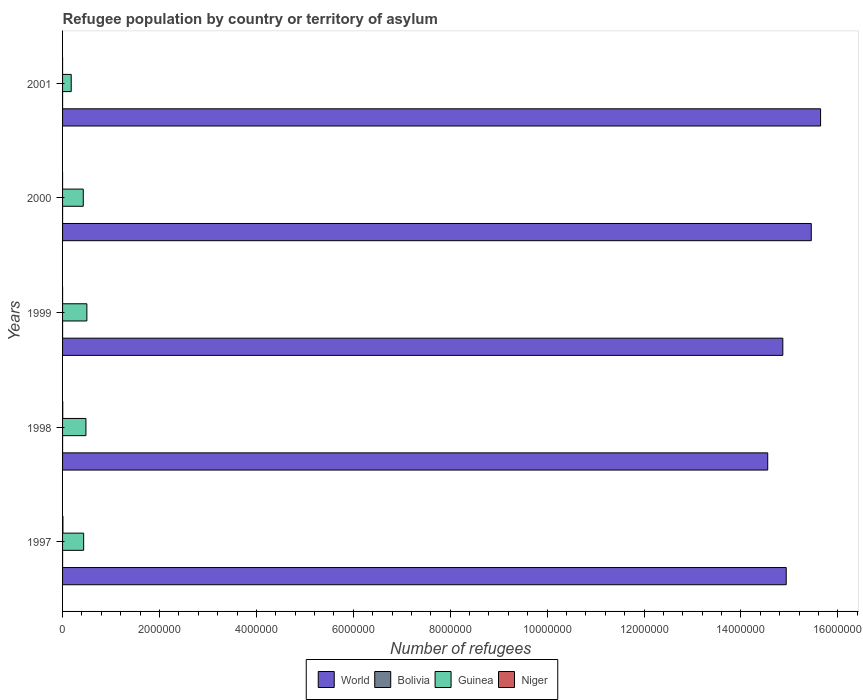How many groups of bars are there?
Offer a very short reply. 5. What is the number of refugees in Niger in 1997?
Make the answer very short. 7376. Across all years, what is the maximum number of refugees in World?
Your answer should be very brief. 1.56e+07. Across all years, what is the minimum number of refugees in Guinea?
Keep it short and to the point. 1.78e+05. What is the total number of refugees in World in the graph?
Provide a succinct answer. 7.54e+07. What is the difference between the number of refugees in Bolivia in 1998 and that in 2000?
Give a very brief answer. -2. What is the difference between the number of refugees in Guinea in 2000 and the number of refugees in World in 1999?
Offer a terse response. -1.44e+07. What is the average number of refugees in Niger per year?
Keep it short and to the point. 2311.6. In the year 1997, what is the difference between the number of refugees in World and number of refugees in Niger?
Offer a very short reply. 1.49e+07. In how many years, is the number of refugees in Bolivia greater than 6400000 ?
Your answer should be very brief. 0. What is the ratio of the number of refugees in Niger in 1998 to that in 2000?
Your response must be concise. 63.64. What is the difference between the highest and the second highest number of refugees in Niger?
Offer a very short reply. 3685. What is the difference between the highest and the lowest number of refugees in Guinea?
Your response must be concise. 3.23e+05. In how many years, is the number of refugees in Niger greater than the average number of refugees in Niger taken over all years?
Your response must be concise. 2. What does the 3rd bar from the bottom in 2001 represents?
Keep it short and to the point. Guinea. Is it the case that in every year, the sum of the number of refugees in Guinea and number of refugees in Bolivia is greater than the number of refugees in World?
Offer a very short reply. No. Are all the bars in the graph horizontal?
Offer a very short reply. Yes. What is the difference between two consecutive major ticks on the X-axis?
Your answer should be very brief. 2.00e+06. Are the values on the major ticks of X-axis written in scientific E-notation?
Make the answer very short. No. Does the graph contain any zero values?
Offer a terse response. No. What is the title of the graph?
Provide a short and direct response. Refugee population by country or territory of asylum. Does "New Caledonia" appear as one of the legend labels in the graph?
Ensure brevity in your answer.  No. What is the label or title of the X-axis?
Give a very brief answer. Number of refugees. What is the Number of refugees of World in 1997?
Offer a very short reply. 1.49e+07. What is the Number of refugees of Bolivia in 1997?
Make the answer very short. 333. What is the Number of refugees of Guinea in 1997?
Ensure brevity in your answer.  4.35e+05. What is the Number of refugees in Niger in 1997?
Give a very brief answer. 7376. What is the Number of refugees in World in 1998?
Keep it short and to the point. 1.46e+07. What is the Number of refugees of Bolivia in 1998?
Offer a terse response. 349. What is the Number of refugees of Guinea in 1998?
Make the answer very short. 4.82e+05. What is the Number of refugees of Niger in 1998?
Keep it short and to the point. 3691. What is the Number of refugees in World in 1999?
Keep it short and to the point. 1.49e+07. What is the Number of refugees in Bolivia in 1999?
Your answer should be very brief. 350. What is the Number of refugees of Guinea in 1999?
Your answer should be very brief. 5.02e+05. What is the Number of refugees of Niger in 1999?
Your response must be concise. 350. What is the Number of refugees in World in 2000?
Provide a succinct answer. 1.55e+07. What is the Number of refugees of Bolivia in 2000?
Ensure brevity in your answer.  351. What is the Number of refugees in Guinea in 2000?
Keep it short and to the point. 4.27e+05. What is the Number of refugees in Niger in 2000?
Offer a very short reply. 58. What is the Number of refugees in World in 2001?
Keep it short and to the point. 1.56e+07. What is the Number of refugees of Bolivia in 2001?
Ensure brevity in your answer.  347. What is the Number of refugees in Guinea in 2001?
Give a very brief answer. 1.78e+05. Across all years, what is the maximum Number of refugees of World?
Give a very brief answer. 1.56e+07. Across all years, what is the maximum Number of refugees in Bolivia?
Provide a succinct answer. 351. Across all years, what is the maximum Number of refugees in Guinea?
Offer a very short reply. 5.02e+05. Across all years, what is the maximum Number of refugees in Niger?
Your answer should be compact. 7376. Across all years, what is the minimum Number of refugees of World?
Your response must be concise. 1.46e+07. Across all years, what is the minimum Number of refugees in Bolivia?
Provide a short and direct response. 333. Across all years, what is the minimum Number of refugees of Guinea?
Keep it short and to the point. 1.78e+05. What is the total Number of refugees of World in the graph?
Provide a succinct answer. 7.54e+07. What is the total Number of refugees of Bolivia in the graph?
Offer a terse response. 1730. What is the total Number of refugees of Guinea in the graph?
Give a very brief answer. 2.02e+06. What is the total Number of refugees in Niger in the graph?
Make the answer very short. 1.16e+04. What is the difference between the Number of refugees of World in 1997 and that in 1998?
Your answer should be compact. 3.82e+05. What is the difference between the Number of refugees in Bolivia in 1997 and that in 1998?
Offer a very short reply. -16. What is the difference between the Number of refugees of Guinea in 1997 and that in 1998?
Provide a succinct answer. -4.72e+04. What is the difference between the Number of refugees of Niger in 1997 and that in 1998?
Offer a very short reply. 3685. What is the difference between the Number of refugees of World in 1997 and that in 1999?
Your answer should be very brief. 7.06e+04. What is the difference between the Number of refugees of Guinea in 1997 and that in 1999?
Offer a very short reply. -6.62e+04. What is the difference between the Number of refugees in Niger in 1997 and that in 1999?
Provide a succinct answer. 7026. What is the difference between the Number of refugees of World in 1997 and that in 2000?
Make the answer very short. -5.17e+05. What is the difference between the Number of refugees of Guinea in 1997 and that in 2000?
Your answer should be very brief. 8094. What is the difference between the Number of refugees of Niger in 1997 and that in 2000?
Your response must be concise. 7318. What is the difference between the Number of refugees in World in 1997 and that in 2001?
Offer a terse response. -7.09e+05. What is the difference between the Number of refugees in Bolivia in 1997 and that in 2001?
Ensure brevity in your answer.  -14. What is the difference between the Number of refugees of Guinea in 1997 and that in 2001?
Your response must be concise. 2.57e+05. What is the difference between the Number of refugees of Niger in 1997 and that in 2001?
Provide a short and direct response. 7293. What is the difference between the Number of refugees in World in 1998 and that in 1999?
Give a very brief answer. -3.12e+05. What is the difference between the Number of refugees of Bolivia in 1998 and that in 1999?
Ensure brevity in your answer.  -1. What is the difference between the Number of refugees in Guinea in 1998 and that in 1999?
Offer a very short reply. -1.91e+04. What is the difference between the Number of refugees of Niger in 1998 and that in 1999?
Make the answer very short. 3341. What is the difference between the Number of refugees in World in 1998 and that in 2000?
Your answer should be compact. -8.99e+05. What is the difference between the Number of refugees in Bolivia in 1998 and that in 2000?
Your answer should be compact. -2. What is the difference between the Number of refugees in Guinea in 1998 and that in 2000?
Provide a succinct answer. 5.53e+04. What is the difference between the Number of refugees in Niger in 1998 and that in 2000?
Keep it short and to the point. 3633. What is the difference between the Number of refugees in World in 1998 and that in 2001?
Provide a succinct answer. -1.09e+06. What is the difference between the Number of refugees in Guinea in 1998 and that in 2001?
Provide a succinct answer. 3.04e+05. What is the difference between the Number of refugees of Niger in 1998 and that in 2001?
Provide a succinct answer. 3608. What is the difference between the Number of refugees in World in 1999 and that in 2000?
Provide a short and direct response. -5.87e+05. What is the difference between the Number of refugees of Bolivia in 1999 and that in 2000?
Offer a terse response. -1. What is the difference between the Number of refugees in Guinea in 1999 and that in 2000?
Your response must be concise. 7.43e+04. What is the difference between the Number of refugees in Niger in 1999 and that in 2000?
Provide a short and direct response. 292. What is the difference between the Number of refugees of World in 1999 and that in 2001?
Your answer should be very brief. -7.79e+05. What is the difference between the Number of refugees of Guinea in 1999 and that in 2001?
Your response must be concise. 3.23e+05. What is the difference between the Number of refugees in Niger in 1999 and that in 2001?
Give a very brief answer. 267. What is the difference between the Number of refugees in World in 2000 and that in 2001?
Your answer should be compact. -1.92e+05. What is the difference between the Number of refugees of Guinea in 2000 and that in 2001?
Give a very brief answer. 2.49e+05. What is the difference between the Number of refugees of Niger in 2000 and that in 2001?
Make the answer very short. -25. What is the difference between the Number of refugees of World in 1997 and the Number of refugees of Bolivia in 1998?
Make the answer very short. 1.49e+07. What is the difference between the Number of refugees in World in 1997 and the Number of refugees in Guinea in 1998?
Ensure brevity in your answer.  1.45e+07. What is the difference between the Number of refugees in World in 1997 and the Number of refugees in Niger in 1998?
Your response must be concise. 1.49e+07. What is the difference between the Number of refugees in Bolivia in 1997 and the Number of refugees in Guinea in 1998?
Your answer should be compact. -4.82e+05. What is the difference between the Number of refugees of Bolivia in 1997 and the Number of refugees of Niger in 1998?
Offer a very short reply. -3358. What is the difference between the Number of refugees in Guinea in 1997 and the Number of refugees in Niger in 1998?
Provide a succinct answer. 4.32e+05. What is the difference between the Number of refugees in World in 1997 and the Number of refugees in Bolivia in 1999?
Provide a short and direct response. 1.49e+07. What is the difference between the Number of refugees of World in 1997 and the Number of refugees of Guinea in 1999?
Give a very brief answer. 1.44e+07. What is the difference between the Number of refugees of World in 1997 and the Number of refugees of Niger in 1999?
Offer a very short reply. 1.49e+07. What is the difference between the Number of refugees in Bolivia in 1997 and the Number of refugees in Guinea in 1999?
Your answer should be very brief. -5.01e+05. What is the difference between the Number of refugees of Bolivia in 1997 and the Number of refugees of Niger in 1999?
Give a very brief answer. -17. What is the difference between the Number of refugees of Guinea in 1997 and the Number of refugees of Niger in 1999?
Ensure brevity in your answer.  4.35e+05. What is the difference between the Number of refugees of World in 1997 and the Number of refugees of Bolivia in 2000?
Your answer should be very brief. 1.49e+07. What is the difference between the Number of refugees of World in 1997 and the Number of refugees of Guinea in 2000?
Provide a succinct answer. 1.45e+07. What is the difference between the Number of refugees of World in 1997 and the Number of refugees of Niger in 2000?
Provide a short and direct response. 1.49e+07. What is the difference between the Number of refugees in Bolivia in 1997 and the Number of refugees in Guinea in 2000?
Ensure brevity in your answer.  -4.27e+05. What is the difference between the Number of refugees in Bolivia in 1997 and the Number of refugees in Niger in 2000?
Provide a succinct answer. 275. What is the difference between the Number of refugees in Guinea in 1997 and the Number of refugees in Niger in 2000?
Provide a short and direct response. 4.35e+05. What is the difference between the Number of refugees of World in 1997 and the Number of refugees of Bolivia in 2001?
Offer a terse response. 1.49e+07. What is the difference between the Number of refugees in World in 1997 and the Number of refugees in Guinea in 2001?
Your answer should be compact. 1.48e+07. What is the difference between the Number of refugees of World in 1997 and the Number of refugees of Niger in 2001?
Give a very brief answer. 1.49e+07. What is the difference between the Number of refugees of Bolivia in 1997 and the Number of refugees of Guinea in 2001?
Your answer should be very brief. -1.78e+05. What is the difference between the Number of refugees in Bolivia in 1997 and the Number of refugees in Niger in 2001?
Give a very brief answer. 250. What is the difference between the Number of refugees in Guinea in 1997 and the Number of refugees in Niger in 2001?
Ensure brevity in your answer.  4.35e+05. What is the difference between the Number of refugees in World in 1998 and the Number of refugees in Bolivia in 1999?
Ensure brevity in your answer.  1.46e+07. What is the difference between the Number of refugees of World in 1998 and the Number of refugees of Guinea in 1999?
Make the answer very short. 1.41e+07. What is the difference between the Number of refugees in World in 1998 and the Number of refugees in Niger in 1999?
Ensure brevity in your answer.  1.46e+07. What is the difference between the Number of refugees of Bolivia in 1998 and the Number of refugees of Guinea in 1999?
Keep it short and to the point. -5.01e+05. What is the difference between the Number of refugees of Guinea in 1998 and the Number of refugees of Niger in 1999?
Your answer should be very brief. 4.82e+05. What is the difference between the Number of refugees in World in 1998 and the Number of refugees in Bolivia in 2000?
Ensure brevity in your answer.  1.46e+07. What is the difference between the Number of refugees of World in 1998 and the Number of refugees of Guinea in 2000?
Provide a succinct answer. 1.41e+07. What is the difference between the Number of refugees in World in 1998 and the Number of refugees in Niger in 2000?
Ensure brevity in your answer.  1.46e+07. What is the difference between the Number of refugees in Bolivia in 1998 and the Number of refugees in Guinea in 2000?
Your response must be concise. -4.27e+05. What is the difference between the Number of refugees in Bolivia in 1998 and the Number of refugees in Niger in 2000?
Your response must be concise. 291. What is the difference between the Number of refugees in Guinea in 1998 and the Number of refugees in Niger in 2000?
Ensure brevity in your answer.  4.82e+05. What is the difference between the Number of refugees in World in 1998 and the Number of refugees in Bolivia in 2001?
Provide a succinct answer. 1.46e+07. What is the difference between the Number of refugees in World in 1998 and the Number of refugees in Guinea in 2001?
Make the answer very short. 1.44e+07. What is the difference between the Number of refugees of World in 1998 and the Number of refugees of Niger in 2001?
Make the answer very short. 1.46e+07. What is the difference between the Number of refugees of Bolivia in 1998 and the Number of refugees of Guinea in 2001?
Your response must be concise. -1.78e+05. What is the difference between the Number of refugees in Bolivia in 1998 and the Number of refugees in Niger in 2001?
Your answer should be very brief. 266. What is the difference between the Number of refugees in Guinea in 1998 and the Number of refugees in Niger in 2001?
Keep it short and to the point. 4.82e+05. What is the difference between the Number of refugees of World in 1999 and the Number of refugees of Bolivia in 2000?
Your answer should be compact. 1.49e+07. What is the difference between the Number of refugees in World in 1999 and the Number of refugees in Guinea in 2000?
Your response must be concise. 1.44e+07. What is the difference between the Number of refugees of World in 1999 and the Number of refugees of Niger in 2000?
Give a very brief answer. 1.49e+07. What is the difference between the Number of refugees in Bolivia in 1999 and the Number of refugees in Guinea in 2000?
Ensure brevity in your answer.  -4.27e+05. What is the difference between the Number of refugees in Bolivia in 1999 and the Number of refugees in Niger in 2000?
Offer a very short reply. 292. What is the difference between the Number of refugees in Guinea in 1999 and the Number of refugees in Niger in 2000?
Your answer should be very brief. 5.01e+05. What is the difference between the Number of refugees in World in 1999 and the Number of refugees in Bolivia in 2001?
Offer a terse response. 1.49e+07. What is the difference between the Number of refugees in World in 1999 and the Number of refugees in Guinea in 2001?
Your answer should be very brief. 1.47e+07. What is the difference between the Number of refugees in World in 1999 and the Number of refugees in Niger in 2001?
Keep it short and to the point. 1.49e+07. What is the difference between the Number of refugees in Bolivia in 1999 and the Number of refugees in Guinea in 2001?
Provide a succinct answer. -1.78e+05. What is the difference between the Number of refugees of Bolivia in 1999 and the Number of refugees of Niger in 2001?
Provide a short and direct response. 267. What is the difference between the Number of refugees in Guinea in 1999 and the Number of refugees in Niger in 2001?
Your answer should be very brief. 5.01e+05. What is the difference between the Number of refugees of World in 2000 and the Number of refugees of Bolivia in 2001?
Your answer should be very brief. 1.55e+07. What is the difference between the Number of refugees of World in 2000 and the Number of refugees of Guinea in 2001?
Ensure brevity in your answer.  1.53e+07. What is the difference between the Number of refugees in World in 2000 and the Number of refugees in Niger in 2001?
Give a very brief answer. 1.55e+07. What is the difference between the Number of refugees in Bolivia in 2000 and the Number of refugees in Guinea in 2001?
Keep it short and to the point. -1.78e+05. What is the difference between the Number of refugees of Bolivia in 2000 and the Number of refugees of Niger in 2001?
Ensure brevity in your answer.  268. What is the difference between the Number of refugees of Guinea in 2000 and the Number of refugees of Niger in 2001?
Keep it short and to the point. 4.27e+05. What is the average Number of refugees in World per year?
Keep it short and to the point. 1.51e+07. What is the average Number of refugees of Bolivia per year?
Your answer should be very brief. 346. What is the average Number of refugees in Guinea per year?
Provide a succinct answer. 4.05e+05. What is the average Number of refugees of Niger per year?
Make the answer very short. 2311.6. In the year 1997, what is the difference between the Number of refugees of World and Number of refugees of Bolivia?
Make the answer very short. 1.49e+07. In the year 1997, what is the difference between the Number of refugees of World and Number of refugees of Guinea?
Provide a succinct answer. 1.45e+07. In the year 1997, what is the difference between the Number of refugees of World and Number of refugees of Niger?
Offer a very short reply. 1.49e+07. In the year 1997, what is the difference between the Number of refugees in Bolivia and Number of refugees in Guinea?
Ensure brevity in your answer.  -4.35e+05. In the year 1997, what is the difference between the Number of refugees of Bolivia and Number of refugees of Niger?
Offer a terse response. -7043. In the year 1997, what is the difference between the Number of refugees of Guinea and Number of refugees of Niger?
Offer a very short reply. 4.28e+05. In the year 1998, what is the difference between the Number of refugees in World and Number of refugees in Bolivia?
Ensure brevity in your answer.  1.46e+07. In the year 1998, what is the difference between the Number of refugees of World and Number of refugees of Guinea?
Ensure brevity in your answer.  1.41e+07. In the year 1998, what is the difference between the Number of refugees of World and Number of refugees of Niger?
Your answer should be compact. 1.45e+07. In the year 1998, what is the difference between the Number of refugees in Bolivia and Number of refugees in Guinea?
Provide a short and direct response. -4.82e+05. In the year 1998, what is the difference between the Number of refugees in Bolivia and Number of refugees in Niger?
Your answer should be compact. -3342. In the year 1998, what is the difference between the Number of refugees of Guinea and Number of refugees of Niger?
Provide a short and direct response. 4.79e+05. In the year 1999, what is the difference between the Number of refugees of World and Number of refugees of Bolivia?
Provide a short and direct response. 1.49e+07. In the year 1999, what is the difference between the Number of refugees in World and Number of refugees in Guinea?
Keep it short and to the point. 1.44e+07. In the year 1999, what is the difference between the Number of refugees of World and Number of refugees of Niger?
Ensure brevity in your answer.  1.49e+07. In the year 1999, what is the difference between the Number of refugees in Bolivia and Number of refugees in Guinea?
Your response must be concise. -5.01e+05. In the year 1999, what is the difference between the Number of refugees of Guinea and Number of refugees of Niger?
Provide a succinct answer. 5.01e+05. In the year 2000, what is the difference between the Number of refugees in World and Number of refugees in Bolivia?
Offer a very short reply. 1.55e+07. In the year 2000, what is the difference between the Number of refugees of World and Number of refugees of Guinea?
Keep it short and to the point. 1.50e+07. In the year 2000, what is the difference between the Number of refugees in World and Number of refugees in Niger?
Provide a short and direct response. 1.55e+07. In the year 2000, what is the difference between the Number of refugees in Bolivia and Number of refugees in Guinea?
Offer a very short reply. -4.27e+05. In the year 2000, what is the difference between the Number of refugees in Bolivia and Number of refugees in Niger?
Provide a short and direct response. 293. In the year 2000, what is the difference between the Number of refugees in Guinea and Number of refugees in Niger?
Offer a very short reply. 4.27e+05. In the year 2001, what is the difference between the Number of refugees in World and Number of refugees in Bolivia?
Give a very brief answer. 1.56e+07. In the year 2001, what is the difference between the Number of refugees of World and Number of refugees of Guinea?
Provide a short and direct response. 1.55e+07. In the year 2001, what is the difference between the Number of refugees in World and Number of refugees in Niger?
Make the answer very short. 1.56e+07. In the year 2001, what is the difference between the Number of refugees in Bolivia and Number of refugees in Guinea?
Provide a succinct answer. -1.78e+05. In the year 2001, what is the difference between the Number of refugees of Bolivia and Number of refugees of Niger?
Ensure brevity in your answer.  264. In the year 2001, what is the difference between the Number of refugees of Guinea and Number of refugees of Niger?
Provide a succinct answer. 1.78e+05. What is the ratio of the Number of refugees in World in 1997 to that in 1998?
Provide a short and direct response. 1.03. What is the ratio of the Number of refugees in Bolivia in 1997 to that in 1998?
Keep it short and to the point. 0.95. What is the ratio of the Number of refugees of Guinea in 1997 to that in 1998?
Keep it short and to the point. 0.9. What is the ratio of the Number of refugees in Niger in 1997 to that in 1998?
Ensure brevity in your answer.  2. What is the ratio of the Number of refugees in Bolivia in 1997 to that in 1999?
Make the answer very short. 0.95. What is the ratio of the Number of refugees of Guinea in 1997 to that in 1999?
Give a very brief answer. 0.87. What is the ratio of the Number of refugees of Niger in 1997 to that in 1999?
Your answer should be very brief. 21.07. What is the ratio of the Number of refugees of World in 1997 to that in 2000?
Your response must be concise. 0.97. What is the ratio of the Number of refugees of Bolivia in 1997 to that in 2000?
Provide a short and direct response. 0.95. What is the ratio of the Number of refugees in Guinea in 1997 to that in 2000?
Your answer should be very brief. 1.02. What is the ratio of the Number of refugees of Niger in 1997 to that in 2000?
Provide a succinct answer. 127.17. What is the ratio of the Number of refugees in World in 1997 to that in 2001?
Keep it short and to the point. 0.95. What is the ratio of the Number of refugees in Bolivia in 1997 to that in 2001?
Keep it short and to the point. 0.96. What is the ratio of the Number of refugees of Guinea in 1997 to that in 2001?
Ensure brevity in your answer.  2.44. What is the ratio of the Number of refugees of Niger in 1997 to that in 2001?
Your response must be concise. 88.87. What is the ratio of the Number of refugees of Bolivia in 1998 to that in 1999?
Give a very brief answer. 1. What is the ratio of the Number of refugees of Niger in 1998 to that in 1999?
Your response must be concise. 10.55. What is the ratio of the Number of refugees in World in 1998 to that in 2000?
Give a very brief answer. 0.94. What is the ratio of the Number of refugees of Bolivia in 1998 to that in 2000?
Give a very brief answer. 0.99. What is the ratio of the Number of refugees of Guinea in 1998 to that in 2000?
Provide a short and direct response. 1.13. What is the ratio of the Number of refugees in Niger in 1998 to that in 2000?
Give a very brief answer. 63.64. What is the ratio of the Number of refugees of World in 1998 to that in 2001?
Your answer should be very brief. 0.93. What is the ratio of the Number of refugees of Guinea in 1998 to that in 2001?
Your answer should be compact. 2.7. What is the ratio of the Number of refugees of Niger in 1998 to that in 2001?
Your answer should be compact. 44.47. What is the ratio of the Number of refugees of Bolivia in 1999 to that in 2000?
Your response must be concise. 1. What is the ratio of the Number of refugees in Guinea in 1999 to that in 2000?
Keep it short and to the point. 1.17. What is the ratio of the Number of refugees in Niger in 1999 to that in 2000?
Provide a short and direct response. 6.03. What is the ratio of the Number of refugees of World in 1999 to that in 2001?
Your answer should be compact. 0.95. What is the ratio of the Number of refugees in Bolivia in 1999 to that in 2001?
Keep it short and to the point. 1.01. What is the ratio of the Number of refugees in Guinea in 1999 to that in 2001?
Give a very brief answer. 2.81. What is the ratio of the Number of refugees of Niger in 1999 to that in 2001?
Your answer should be compact. 4.22. What is the ratio of the Number of refugees of World in 2000 to that in 2001?
Your answer should be very brief. 0.99. What is the ratio of the Number of refugees of Bolivia in 2000 to that in 2001?
Give a very brief answer. 1.01. What is the ratio of the Number of refugees of Guinea in 2000 to that in 2001?
Your response must be concise. 2.39. What is the ratio of the Number of refugees of Niger in 2000 to that in 2001?
Make the answer very short. 0.7. What is the difference between the highest and the second highest Number of refugees in World?
Your answer should be very brief. 1.92e+05. What is the difference between the highest and the second highest Number of refugees of Bolivia?
Your answer should be compact. 1. What is the difference between the highest and the second highest Number of refugees of Guinea?
Provide a short and direct response. 1.91e+04. What is the difference between the highest and the second highest Number of refugees of Niger?
Offer a very short reply. 3685. What is the difference between the highest and the lowest Number of refugees of World?
Make the answer very short. 1.09e+06. What is the difference between the highest and the lowest Number of refugees in Bolivia?
Provide a short and direct response. 18. What is the difference between the highest and the lowest Number of refugees in Guinea?
Offer a terse response. 3.23e+05. What is the difference between the highest and the lowest Number of refugees of Niger?
Keep it short and to the point. 7318. 